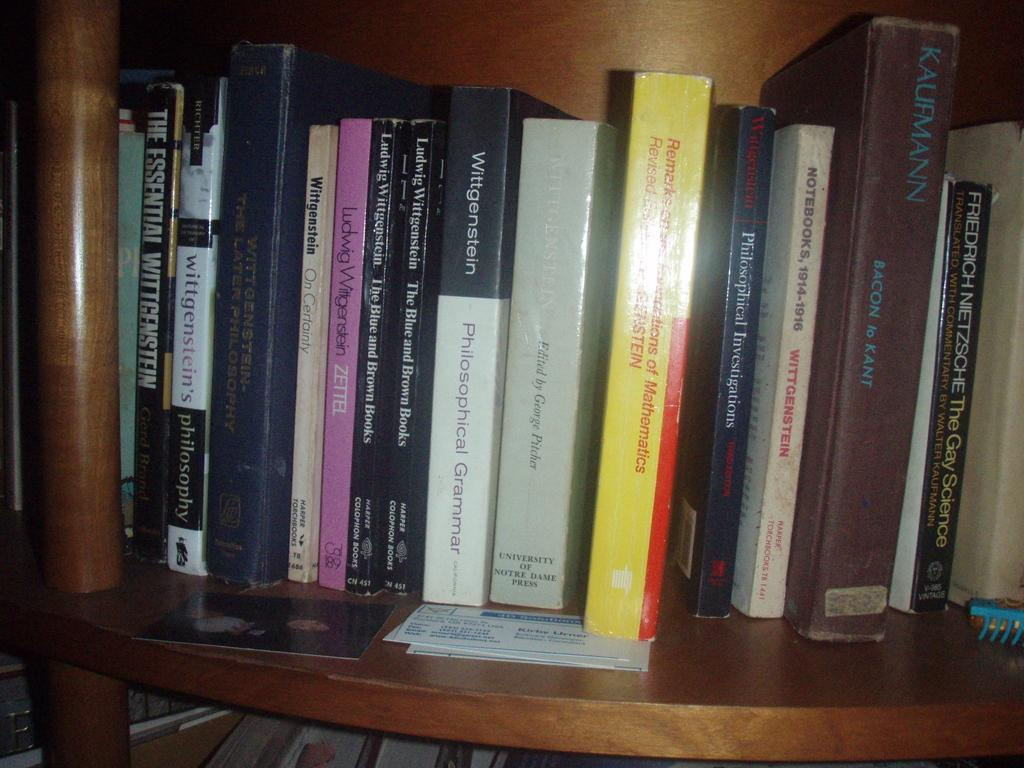<image>
Present a compact description of the photo's key features. A selection of books on a shelf, the yellow one is about mathematics. 